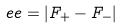Convert formula to latex. <formula><loc_0><loc_0><loc_500><loc_500>e e = | F _ { + } - F _ { - } |</formula> 